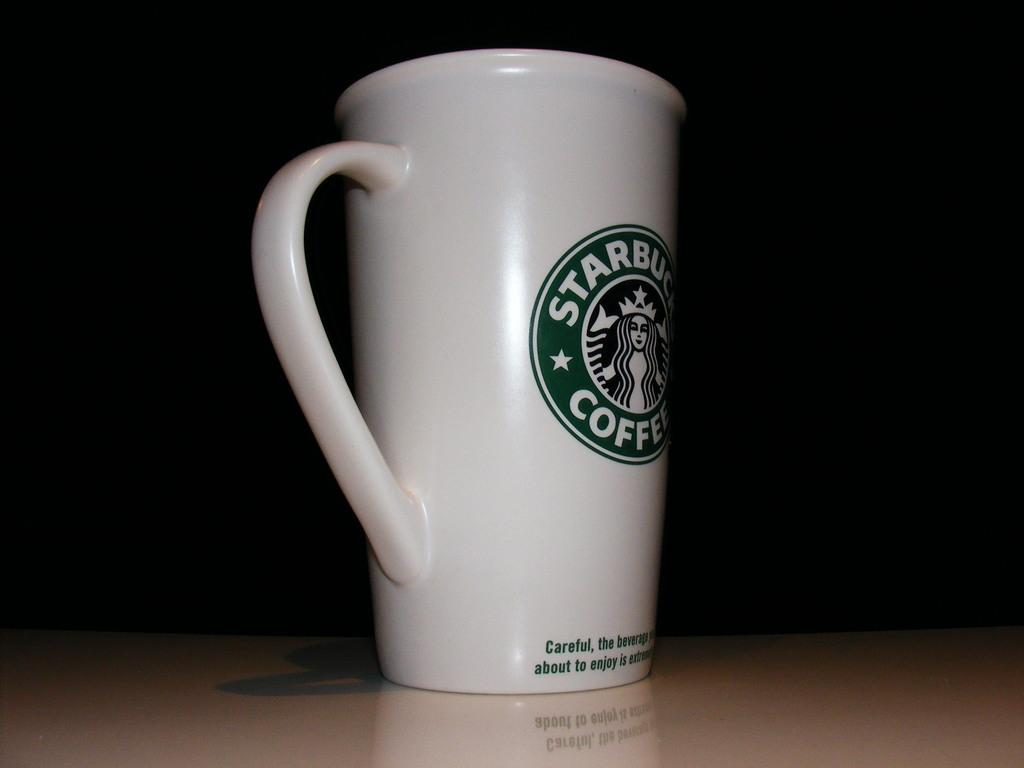<image>
Provide a brief description of the given image. a Starbucks Coffee mug on a dark background 